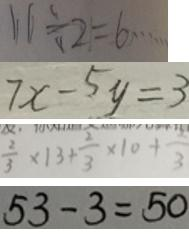Convert formula to latex. <formula><loc_0><loc_0><loc_500><loc_500>1 1 \div 2 = 6 \cdots 
 7 x - 5 y = 3 
 \frac { 2 } { 3 } \times 1 3 + \frac { 2 } { 3 } \times 1 0 + \frac { 2 } { 3 } 
 5 3 - 3 = 5 0</formula> 